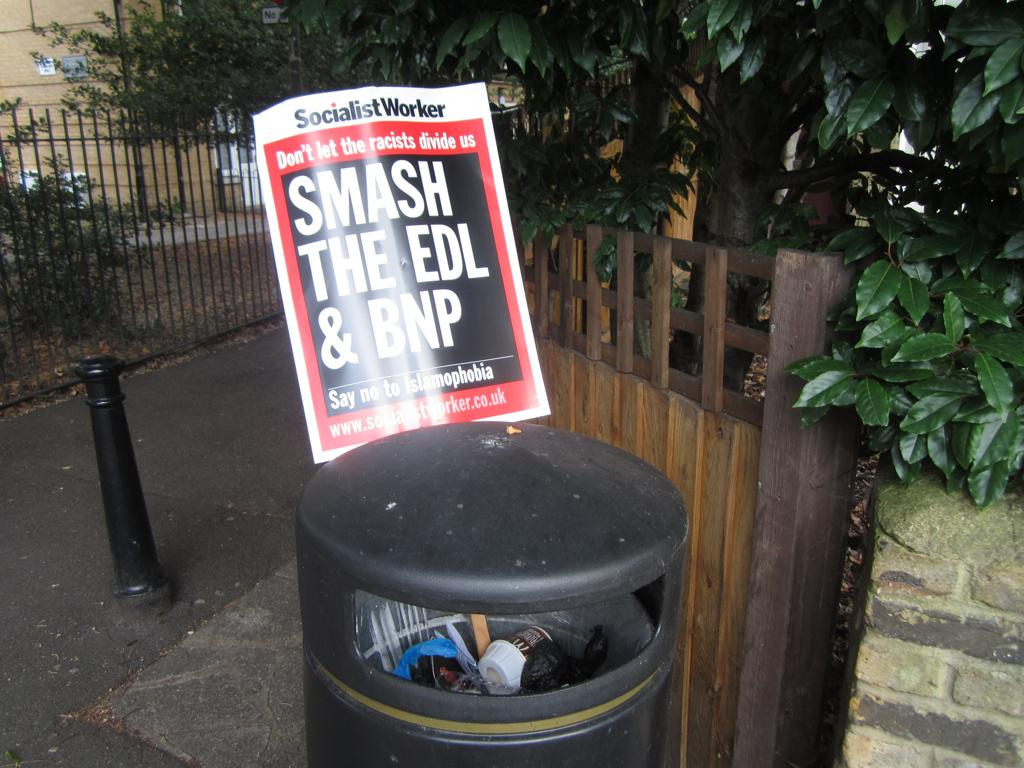<image>
Relay a brief, clear account of the picture shown. A garbage bin with a copy of the Socialist Worker on top of it. 